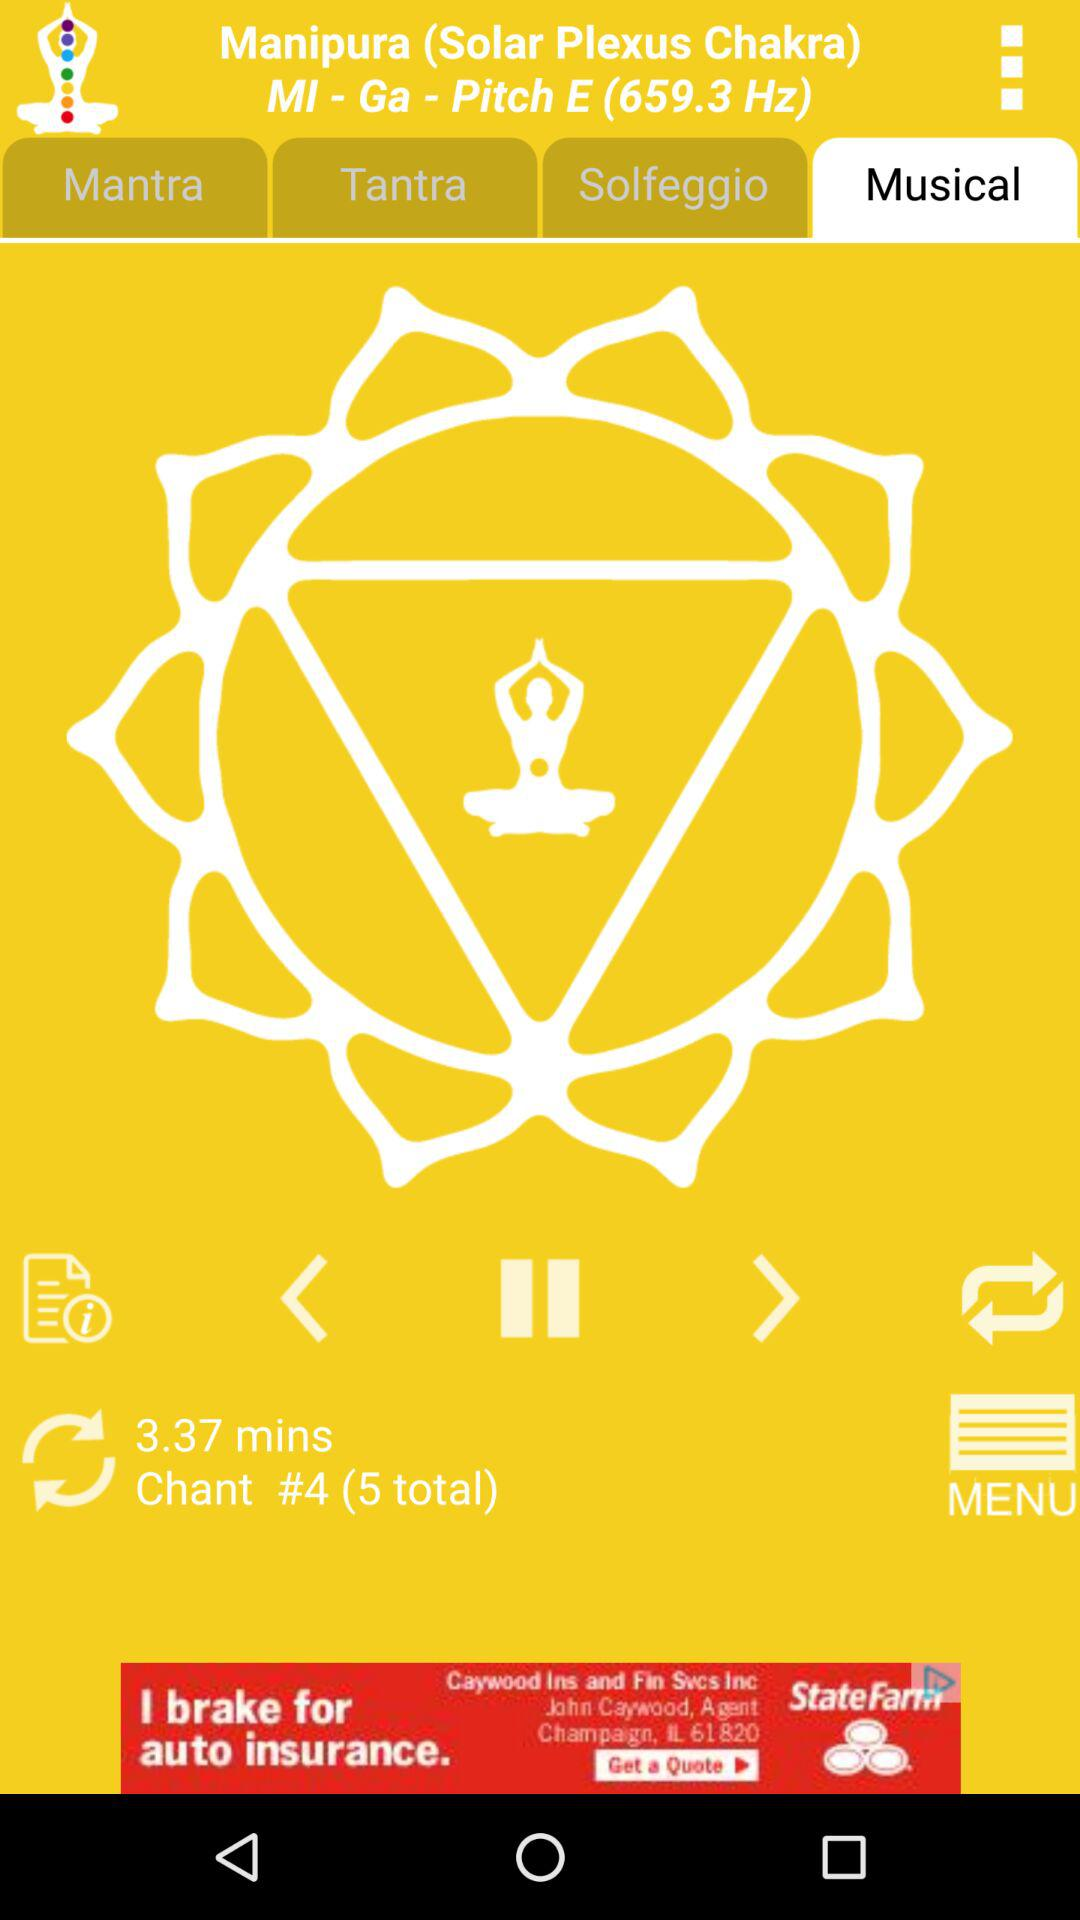What's the total number of chants? The total number of chants is 5. 